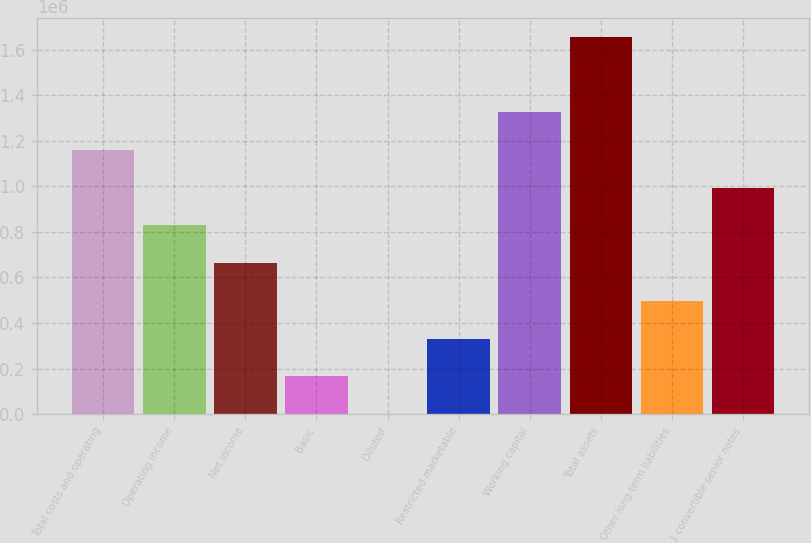Convert chart. <chart><loc_0><loc_0><loc_500><loc_500><bar_chart><fcel>Total costs and operating<fcel>Operating income<fcel>Net income<fcel>Basic<fcel>Diluted<fcel>Restricted marketable<fcel>Working capital<fcel>Total assets<fcel>Other long-term liabilities<fcel>1 convertible senior notes<nl><fcel>1.15923e+06<fcel>828024<fcel>662419<fcel>165605<fcel>0.56<fcel>331210<fcel>1.32484e+06<fcel>1.65605e+06<fcel>496814<fcel>993628<nl></chart> 